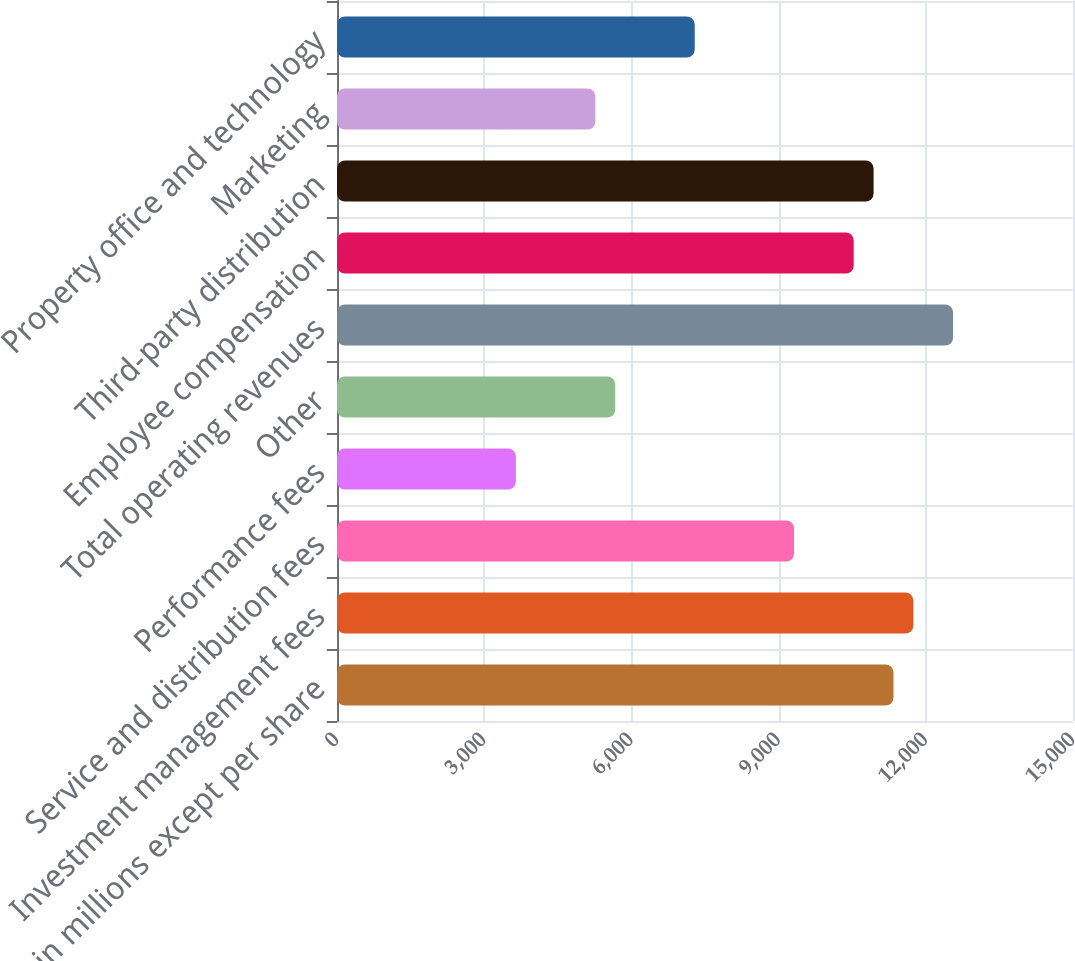Convert chart to OTSL. <chart><loc_0><loc_0><loc_500><loc_500><bar_chart><fcel>in millions except per share<fcel>Investment management fees<fcel>Service and distribution fees<fcel>Performance fees<fcel>Other<fcel>Total operating revenues<fcel>Employee compensation<fcel>Third-party distribution<fcel>Marketing<fcel>Property office and technology<nl><fcel>11341.2<fcel>11746.2<fcel>9315.96<fcel>3645.4<fcel>5670.6<fcel>12556.3<fcel>10531.1<fcel>10936.1<fcel>5265.56<fcel>7290.76<nl></chart> 